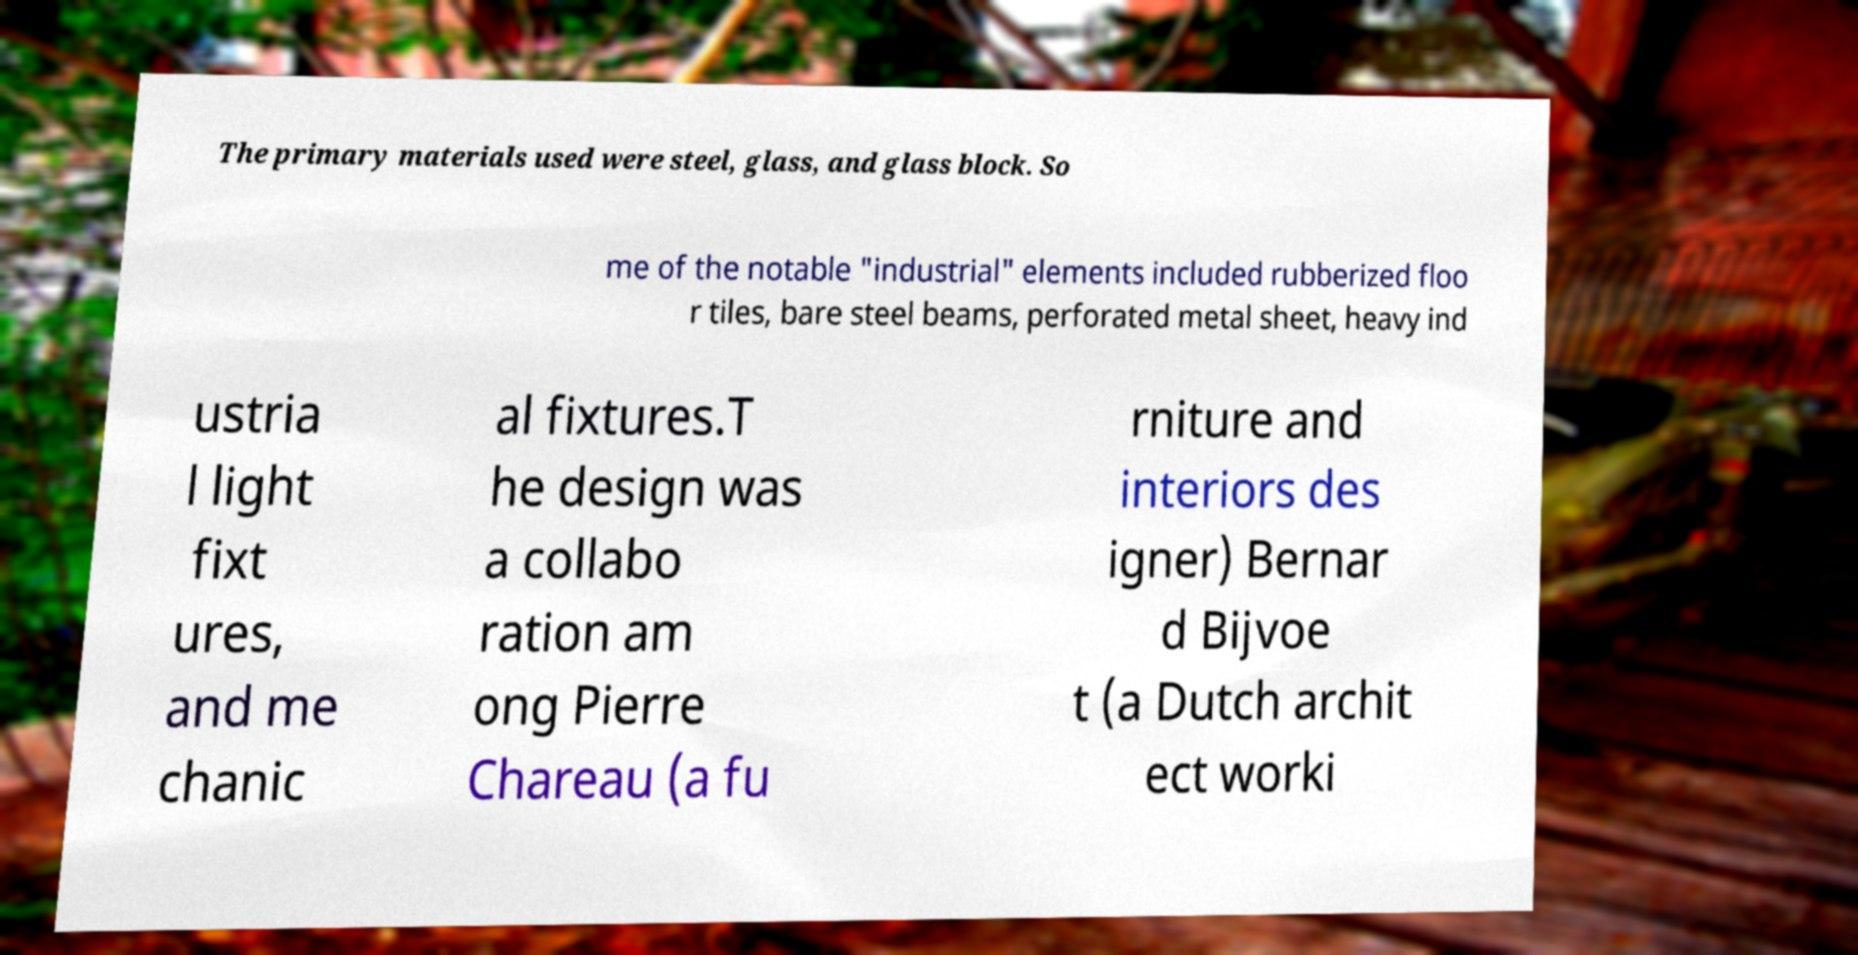Can you accurately transcribe the text from the provided image for me? The primary materials used were steel, glass, and glass block. So me of the notable "industrial" elements included rubberized floo r tiles, bare steel beams, perforated metal sheet, heavy ind ustria l light fixt ures, and me chanic al fixtures.T he design was a collabo ration am ong Pierre Chareau (a fu rniture and interiors des igner) Bernar d Bijvoe t (a Dutch archit ect worki 